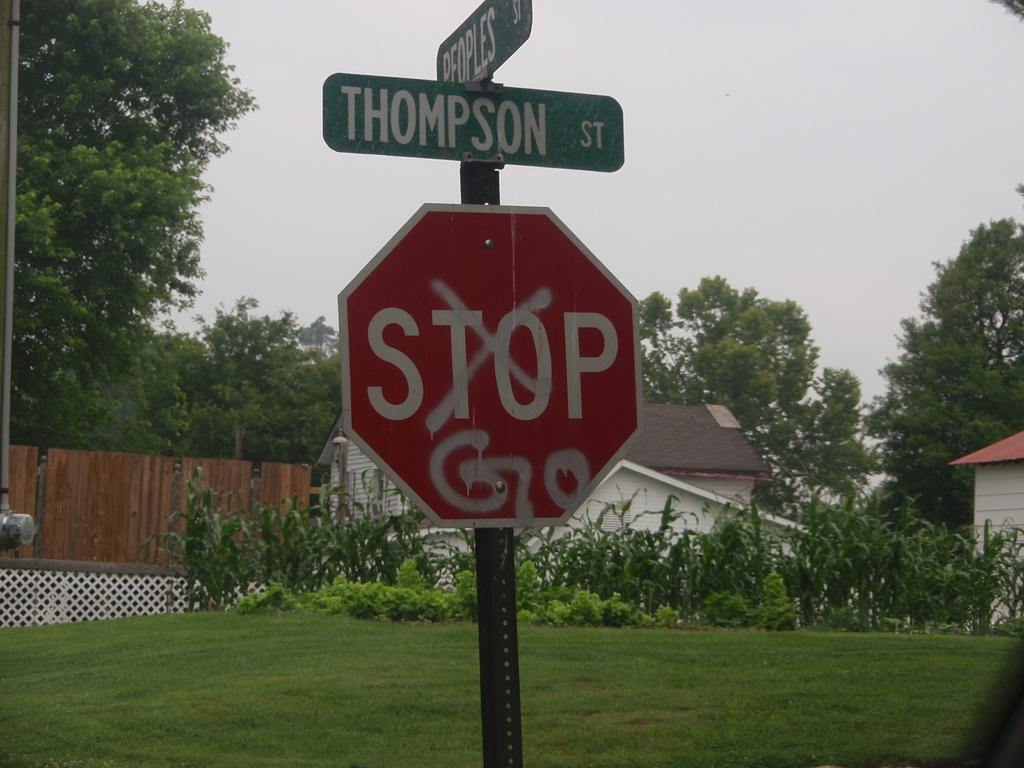<image>
Create a compact narrative representing the image presented. A vandalized red and white stop sign has a green street sign that reads thompson on top ofit. 